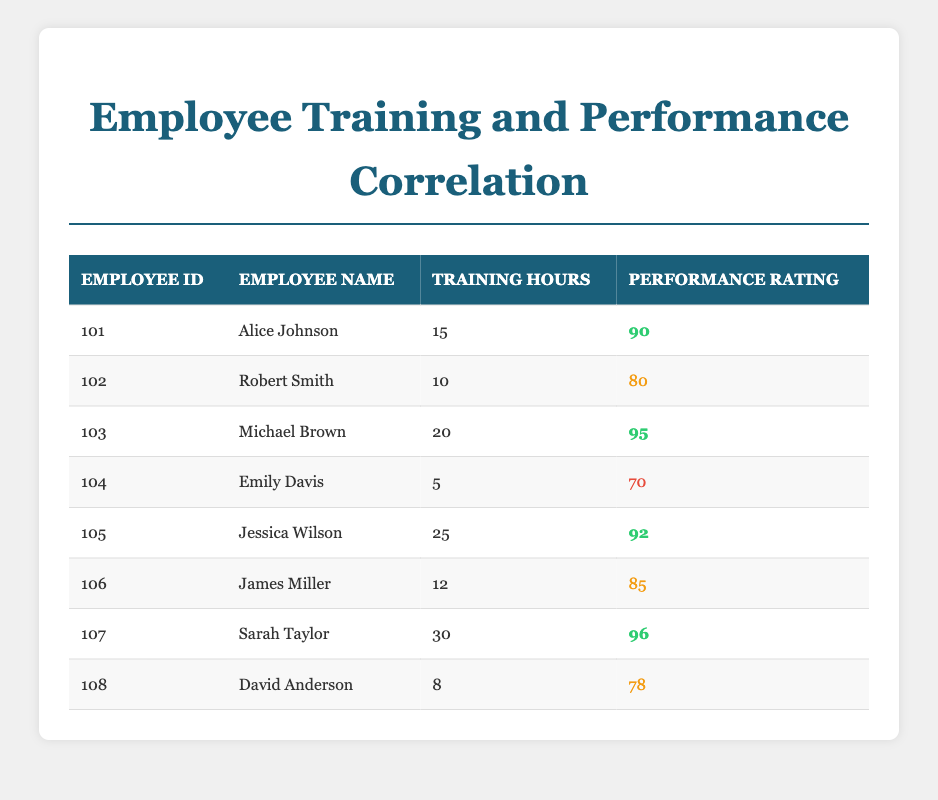What is the performance rating of Sarah Taylor? In the table, I can find Sarah Taylor's row and see that her performance rating is listed as 96.
Answer: 96 How many training hours did Jessica Wilson receive? Looking at Jessica Wilson's row, I can see that she received 25 training hours.
Answer: 25 What is the average performance rating of employees who received more than 20 training hours? The employees with more than 20 training hours are Michael Brown, Jessica Wilson, and Sarah Taylor, with performance ratings of 95, 92, and 96, respectively. The sum of these ratings is 95 + 92 + 96 = 283. There are 3 employees, so the average is 283/3 = 94.33.
Answer: 94.33 Did any employee with less than 10 training hours achieve a performance rating higher than 80? Referring to the table, David Anderson has 8 training hours and a performance rating of 78, while Emily Davis has 5 training hours and a performance rating of 70. Both ratings are below 80, indicating no such employee exists.
Answer: No Which employee spent the most training hours and what is their performance rating? In the table, I identify that Sarah Taylor has the maximum training hours at 30. Her performance rating is 96.
Answer: Sarah Taylor, 96 What is the total sum of training hours for all employees with a performance rating of 85 or higher? The employees with a performance rating of 85 or higher are Alice Johnson, Michael Brown, Jessica Wilson, Sarah Taylor, and James Miller, with training hours of 15, 20, 25, 30, and 12 respectively. The sum is 15 + 20 + 25 + 30 + 12 = 102.
Answer: 102 Is there an employee who has a performance rating of 70 and received 5 training hours? Emily Davis is the only employee listed with 5 training hours, and her performance rating is 70, confirming this fact.
Answer: Yes What is the difference in performance rating between the employee with the least training hours and the one with the most? The employee with the least training hours is Emily Davis with a rating of 70 and the most is Sarah Taylor with a rating of 96. The difference is 96 - 70 = 26.
Answer: 26 